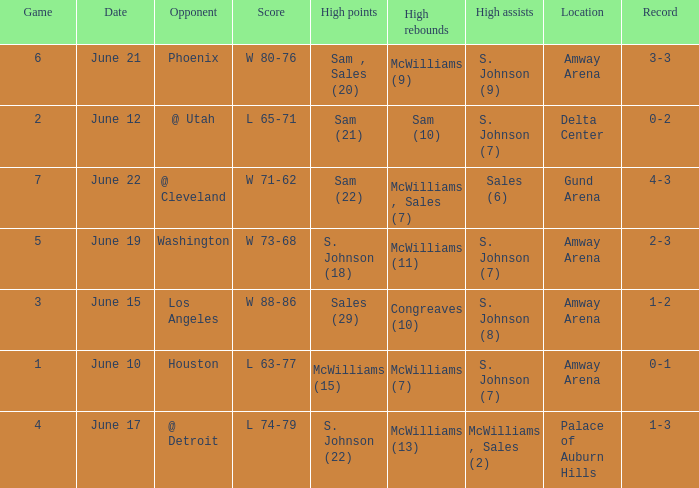Name the opponent for june 12 @ Utah. 